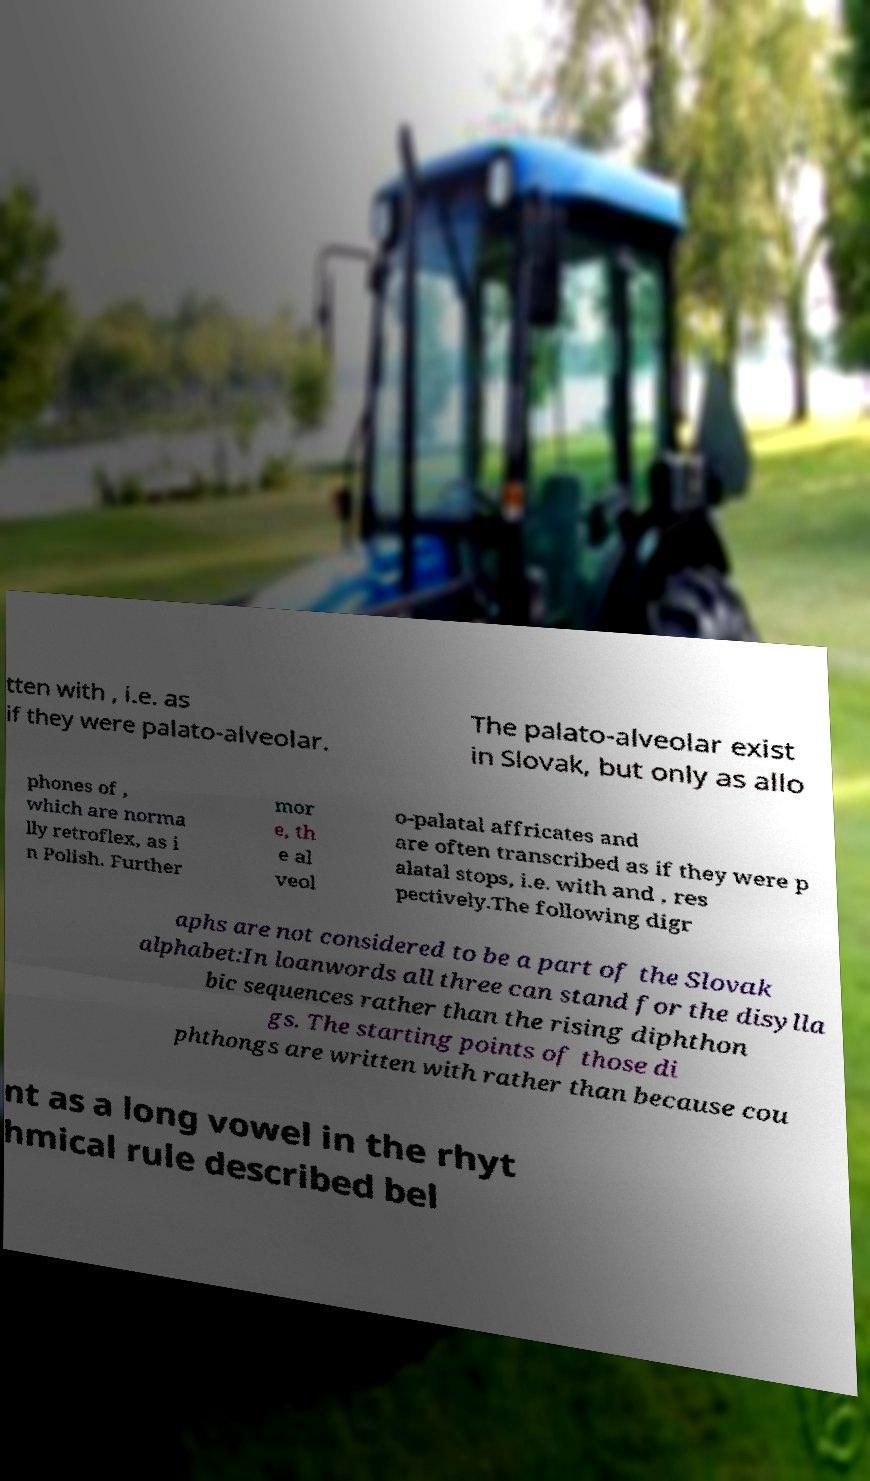Please identify and transcribe the text found in this image. tten with , i.e. as if they were palato-alveolar. The palato-alveolar exist in Slovak, but only as allo phones of , which are norma lly retroflex, as i n Polish. Further mor e, th e al veol o-palatal affricates and are often transcribed as if they were p alatal stops, i.e. with and , res pectively.The following digr aphs are not considered to be a part of the Slovak alphabet:In loanwords all three can stand for the disylla bic sequences rather than the rising diphthon gs. The starting points of those di phthongs are written with rather than because cou nt as a long vowel in the rhyt hmical rule described bel 